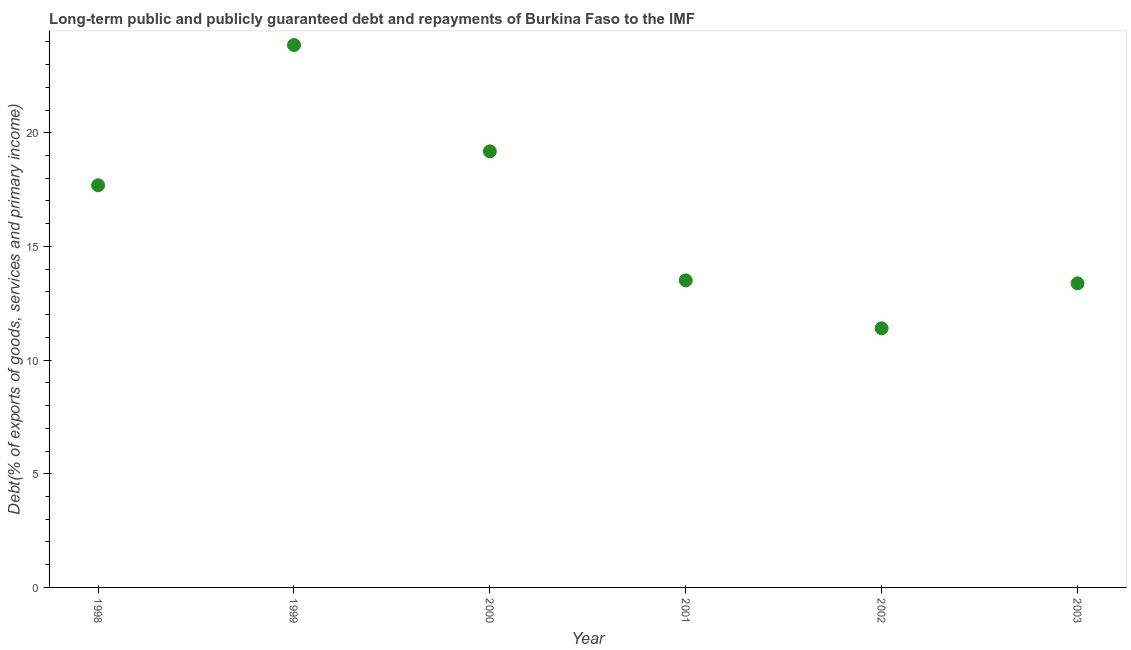What is the debt service in 2003?
Offer a terse response. 13.37. Across all years, what is the maximum debt service?
Keep it short and to the point. 23.86. Across all years, what is the minimum debt service?
Make the answer very short. 11.4. In which year was the debt service minimum?
Offer a very short reply. 2002. What is the sum of the debt service?
Offer a very short reply. 99.01. What is the difference between the debt service in 1998 and 2003?
Keep it short and to the point. 4.32. What is the average debt service per year?
Provide a short and direct response. 16.5. What is the median debt service?
Offer a terse response. 15.6. In how many years, is the debt service greater than 23 %?
Offer a terse response. 1. Do a majority of the years between 2003 and 2001 (inclusive) have debt service greater than 4 %?
Offer a very short reply. No. What is the ratio of the debt service in 1998 to that in 2003?
Your answer should be very brief. 1.32. What is the difference between the highest and the second highest debt service?
Your response must be concise. 4.68. What is the difference between the highest and the lowest debt service?
Your response must be concise. 12.46. Does the graph contain grids?
Make the answer very short. No. What is the title of the graph?
Ensure brevity in your answer.  Long-term public and publicly guaranteed debt and repayments of Burkina Faso to the IMF. What is the label or title of the X-axis?
Keep it short and to the point. Year. What is the label or title of the Y-axis?
Keep it short and to the point. Debt(% of exports of goods, services and primary income). What is the Debt(% of exports of goods, services and primary income) in 1998?
Offer a terse response. 17.69. What is the Debt(% of exports of goods, services and primary income) in 1999?
Provide a short and direct response. 23.86. What is the Debt(% of exports of goods, services and primary income) in 2000?
Offer a very short reply. 19.18. What is the Debt(% of exports of goods, services and primary income) in 2001?
Provide a succinct answer. 13.51. What is the Debt(% of exports of goods, services and primary income) in 2002?
Your response must be concise. 11.4. What is the Debt(% of exports of goods, services and primary income) in 2003?
Your response must be concise. 13.37. What is the difference between the Debt(% of exports of goods, services and primary income) in 1998 and 1999?
Your response must be concise. -6.17. What is the difference between the Debt(% of exports of goods, services and primary income) in 1998 and 2000?
Your response must be concise. -1.49. What is the difference between the Debt(% of exports of goods, services and primary income) in 1998 and 2001?
Give a very brief answer. 4.18. What is the difference between the Debt(% of exports of goods, services and primary income) in 1998 and 2002?
Your response must be concise. 6.29. What is the difference between the Debt(% of exports of goods, services and primary income) in 1998 and 2003?
Make the answer very short. 4.32. What is the difference between the Debt(% of exports of goods, services and primary income) in 1999 and 2000?
Your answer should be compact. 4.68. What is the difference between the Debt(% of exports of goods, services and primary income) in 1999 and 2001?
Your answer should be very brief. 10.35. What is the difference between the Debt(% of exports of goods, services and primary income) in 1999 and 2002?
Your answer should be very brief. 12.46. What is the difference between the Debt(% of exports of goods, services and primary income) in 1999 and 2003?
Keep it short and to the point. 10.49. What is the difference between the Debt(% of exports of goods, services and primary income) in 2000 and 2001?
Make the answer very short. 5.67. What is the difference between the Debt(% of exports of goods, services and primary income) in 2000 and 2002?
Offer a very short reply. 7.78. What is the difference between the Debt(% of exports of goods, services and primary income) in 2000 and 2003?
Provide a short and direct response. 5.81. What is the difference between the Debt(% of exports of goods, services and primary income) in 2001 and 2002?
Your answer should be compact. 2.11. What is the difference between the Debt(% of exports of goods, services and primary income) in 2001 and 2003?
Offer a very short reply. 0.13. What is the difference between the Debt(% of exports of goods, services and primary income) in 2002 and 2003?
Give a very brief answer. -1.98. What is the ratio of the Debt(% of exports of goods, services and primary income) in 1998 to that in 1999?
Keep it short and to the point. 0.74. What is the ratio of the Debt(% of exports of goods, services and primary income) in 1998 to that in 2000?
Keep it short and to the point. 0.92. What is the ratio of the Debt(% of exports of goods, services and primary income) in 1998 to that in 2001?
Your answer should be very brief. 1.31. What is the ratio of the Debt(% of exports of goods, services and primary income) in 1998 to that in 2002?
Ensure brevity in your answer.  1.55. What is the ratio of the Debt(% of exports of goods, services and primary income) in 1998 to that in 2003?
Give a very brief answer. 1.32. What is the ratio of the Debt(% of exports of goods, services and primary income) in 1999 to that in 2000?
Keep it short and to the point. 1.24. What is the ratio of the Debt(% of exports of goods, services and primary income) in 1999 to that in 2001?
Your answer should be compact. 1.77. What is the ratio of the Debt(% of exports of goods, services and primary income) in 1999 to that in 2002?
Offer a terse response. 2.09. What is the ratio of the Debt(% of exports of goods, services and primary income) in 1999 to that in 2003?
Your answer should be compact. 1.78. What is the ratio of the Debt(% of exports of goods, services and primary income) in 2000 to that in 2001?
Give a very brief answer. 1.42. What is the ratio of the Debt(% of exports of goods, services and primary income) in 2000 to that in 2002?
Ensure brevity in your answer.  1.68. What is the ratio of the Debt(% of exports of goods, services and primary income) in 2000 to that in 2003?
Offer a very short reply. 1.43. What is the ratio of the Debt(% of exports of goods, services and primary income) in 2001 to that in 2002?
Offer a terse response. 1.19. What is the ratio of the Debt(% of exports of goods, services and primary income) in 2002 to that in 2003?
Your answer should be very brief. 0.85. 